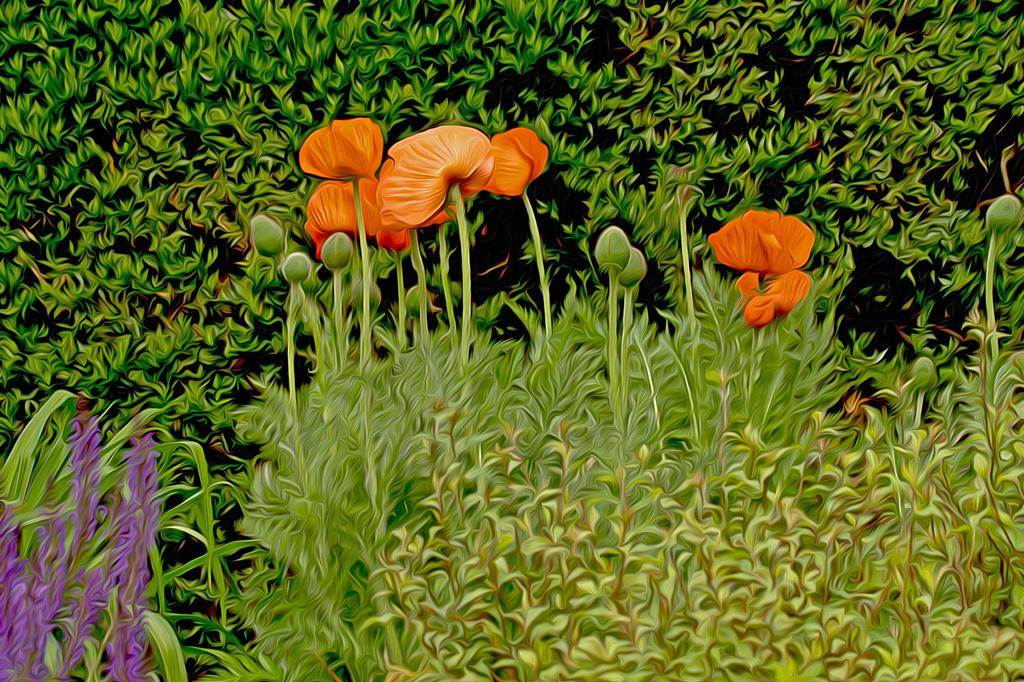What type of living organisms can be seen in the image? Plants, buds, and flowers are visible in the image. Can you describe the growth stage of the plants in the image? The plants in the image have buds, which suggests they are in the process of blooming. What is the result of the plants' growth in the image? The result of the plants' growth is the presence of flowers in the image. What type of committee can be seen in the image? There is no committee present in the image; it features plants, buds, and flowers. What kind of spade is being used to dig up the flowers in the image? There is no spade or digging activity present in the image; it only shows plants, buds, and flowers. 